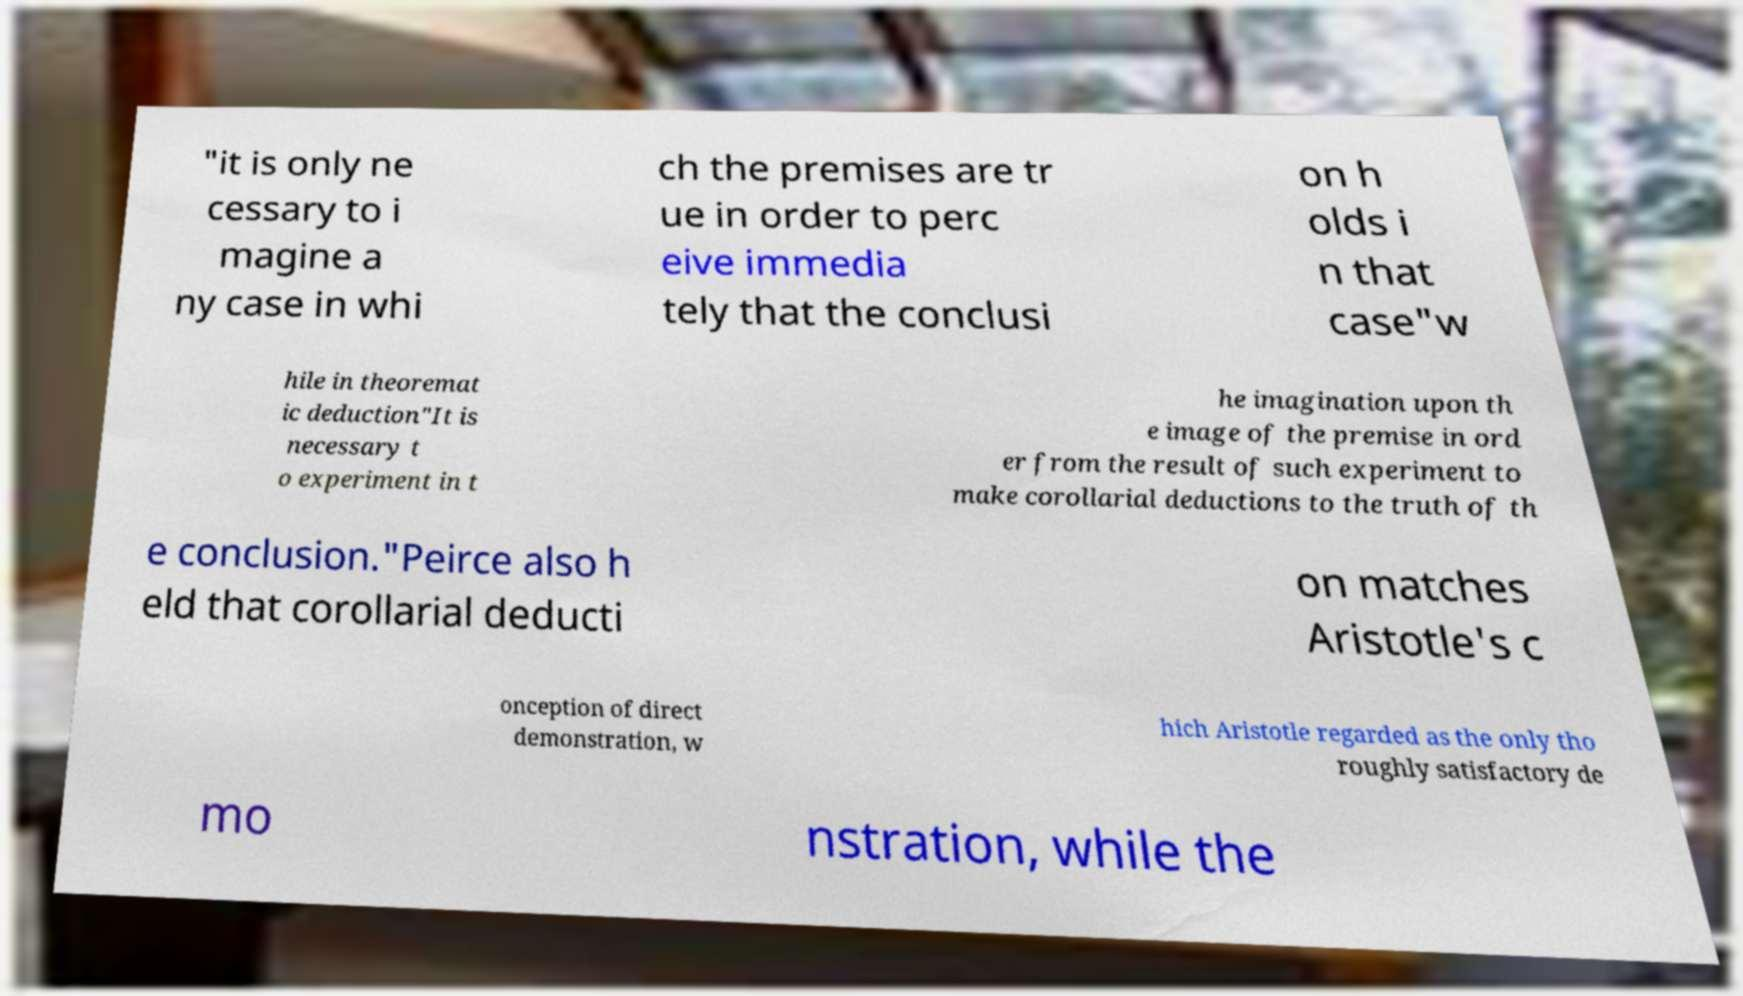Could you assist in decoding the text presented in this image and type it out clearly? "it is only ne cessary to i magine a ny case in whi ch the premises are tr ue in order to perc eive immedia tely that the conclusi on h olds i n that case"w hile in theoremat ic deduction"It is necessary t o experiment in t he imagination upon th e image of the premise in ord er from the result of such experiment to make corollarial deductions to the truth of th e conclusion."Peirce also h eld that corollarial deducti on matches Aristotle's c onception of direct demonstration, w hich Aristotle regarded as the only tho roughly satisfactory de mo nstration, while the 